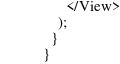Convert code to text. <code><loc_0><loc_0><loc_500><loc_500><_TypeScript_>      </View>
    );
  }
}
</code> 